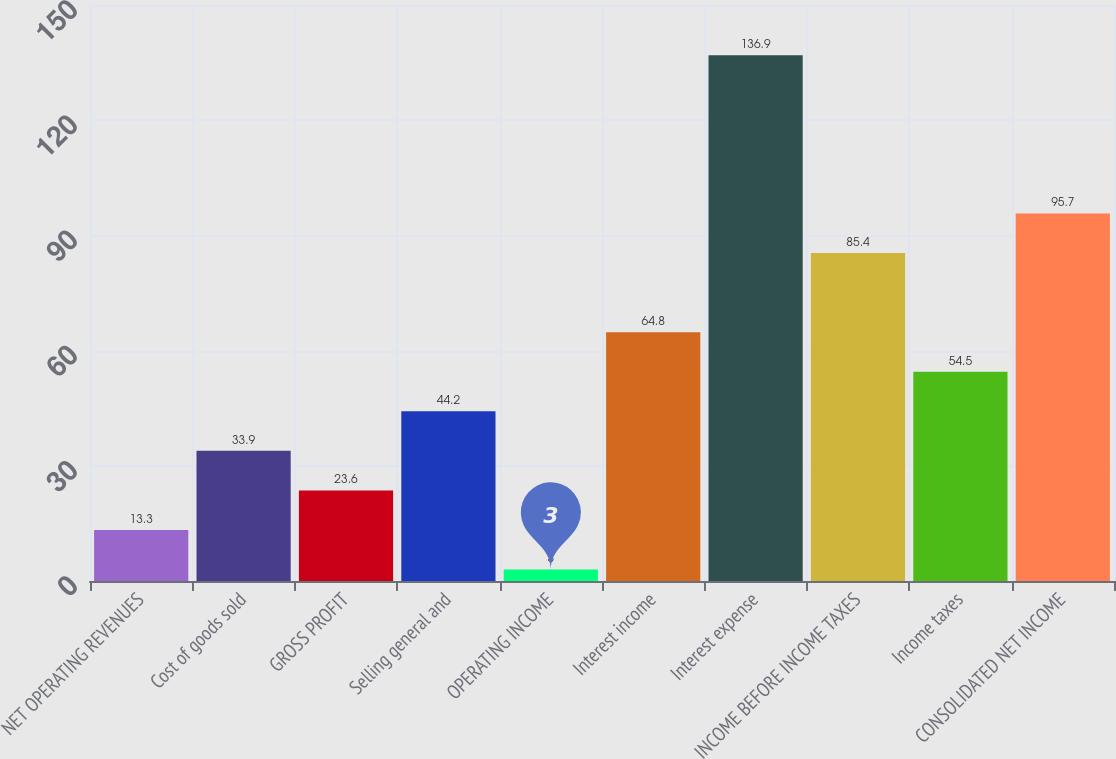Convert chart. <chart><loc_0><loc_0><loc_500><loc_500><bar_chart><fcel>NET OPERATING REVENUES<fcel>Cost of goods sold<fcel>GROSS PROFIT<fcel>Selling general and<fcel>OPERATING INCOME<fcel>Interest income<fcel>Interest expense<fcel>INCOME BEFORE INCOME TAXES<fcel>Income taxes<fcel>CONSOLIDATED NET INCOME<nl><fcel>13.3<fcel>33.9<fcel>23.6<fcel>44.2<fcel>3<fcel>64.8<fcel>136.9<fcel>85.4<fcel>54.5<fcel>95.7<nl></chart> 